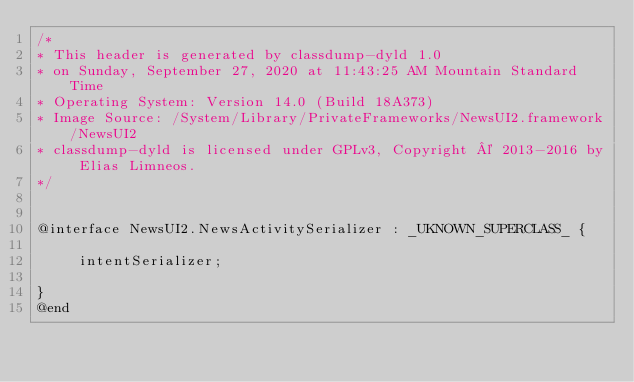<code> <loc_0><loc_0><loc_500><loc_500><_C_>/*
* This header is generated by classdump-dyld 1.0
* on Sunday, September 27, 2020 at 11:43:25 AM Mountain Standard Time
* Operating System: Version 14.0 (Build 18A373)
* Image Source: /System/Library/PrivateFrameworks/NewsUI2.framework/NewsUI2
* classdump-dyld is licensed under GPLv3, Copyright © 2013-2016 by Elias Limneos.
*/


@interface NewsUI2.NewsActivitySerializer : _UKNOWN_SUPERCLASS_ {

	 intentSerializer;

}
@end

</code> 